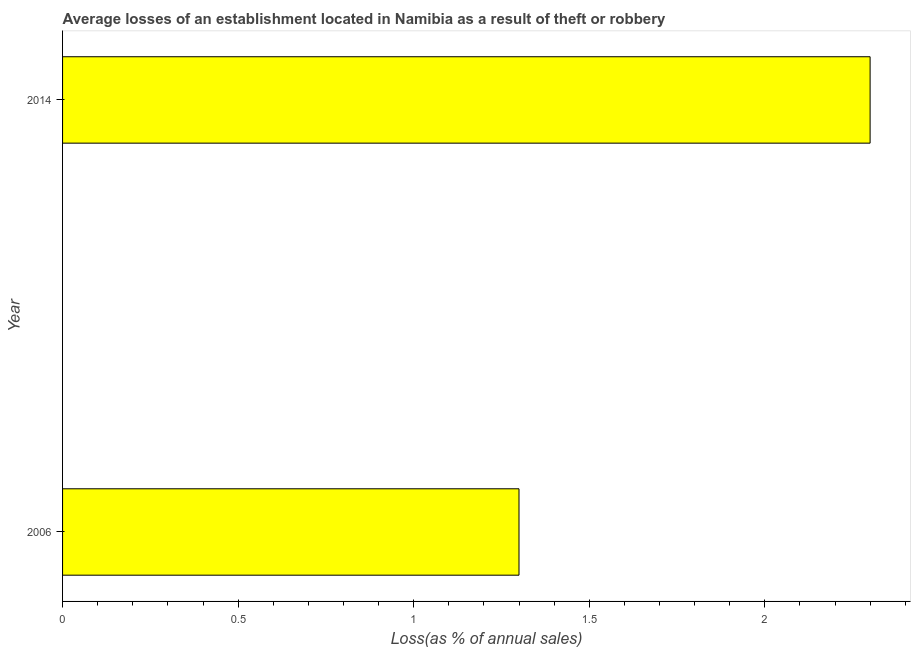Does the graph contain any zero values?
Your answer should be compact. No. What is the title of the graph?
Offer a terse response. Average losses of an establishment located in Namibia as a result of theft or robbery. What is the label or title of the X-axis?
Your answer should be compact. Loss(as % of annual sales). What is the label or title of the Y-axis?
Give a very brief answer. Year. What is the losses due to theft in 2006?
Give a very brief answer. 1.3. Across all years, what is the maximum losses due to theft?
Provide a short and direct response. 2.3. Across all years, what is the minimum losses due to theft?
Make the answer very short. 1.3. What is the sum of the losses due to theft?
Offer a very short reply. 3.6. What is the difference between the losses due to theft in 2006 and 2014?
Make the answer very short. -1. What is the median losses due to theft?
Provide a succinct answer. 1.8. In how many years, is the losses due to theft greater than 1.2 %?
Your answer should be very brief. 2. Do a majority of the years between 2014 and 2006 (inclusive) have losses due to theft greater than 0.7 %?
Give a very brief answer. No. What is the ratio of the losses due to theft in 2006 to that in 2014?
Make the answer very short. 0.56. Is the losses due to theft in 2006 less than that in 2014?
Your answer should be very brief. Yes. In how many years, is the losses due to theft greater than the average losses due to theft taken over all years?
Make the answer very short. 1. Are all the bars in the graph horizontal?
Your answer should be compact. Yes. How many years are there in the graph?
Provide a succinct answer. 2. What is the difference between two consecutive major ticks on the X-axis?
Ensure brevity in your answer.  0.5. Are the values on the major ticks of X-axis written in scientific E-notation?
Your response must be concise. No. What is the Loss(as % of annual sales) of 2006?
Give a very brief answer. 1.3. What is the difference between the Loss(as % of annual sales) in 2006 and 2014?
Provide a succinct answer. -1. What is the ratio of the Loss(as % of annual sales) in 2006 to that in 2014?
Ensure brevity in your answer.  0.56. 